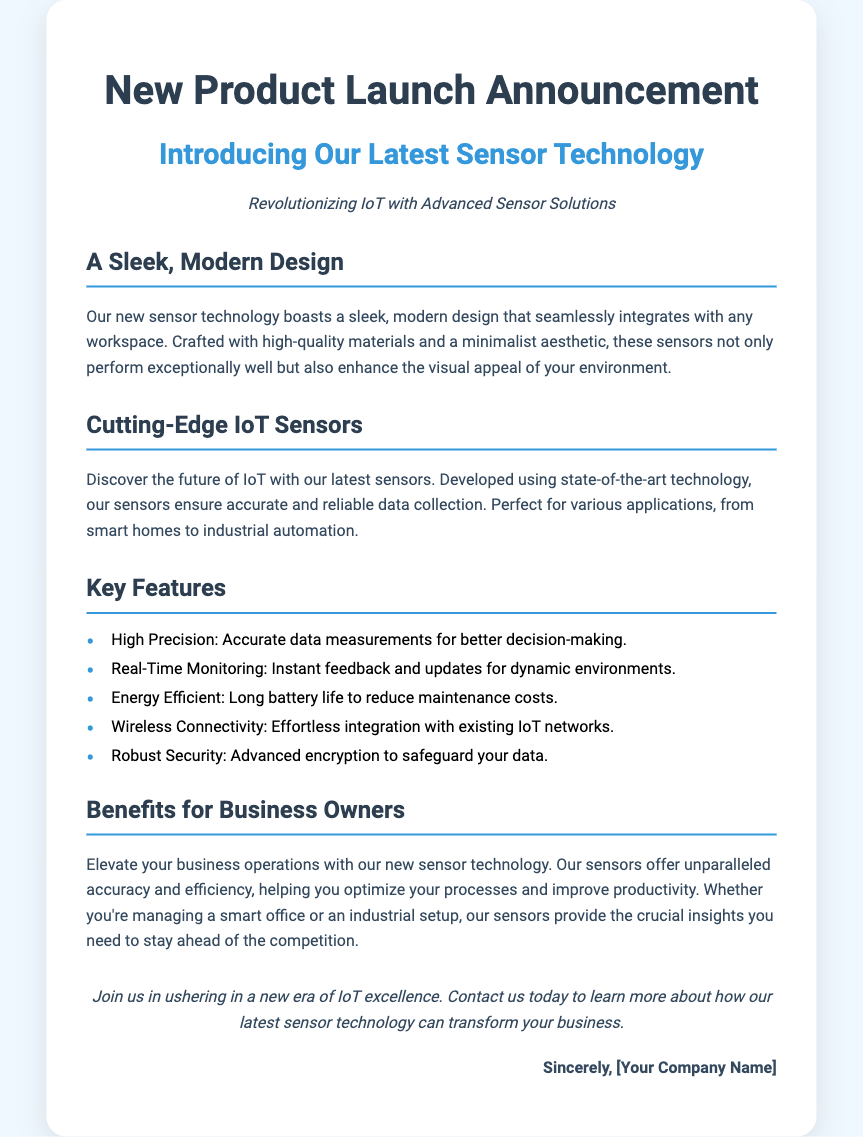What is the title of the announcement? The title of the announcement is provided at the top of the document.
Answer: New Product Launch Announcement What is the main focus of the new technology? The main focus of the new technology is highlighted in the introduction section of the document.
Answer: Latest Sensor Technology What is one key feature of the sensors? The document lists features in a section, providing multiple options.
Answer: High Precision What type of environment is mentioned for these sensors? The document specifies examples of environments suitable for the sensors' applications.
Answer: Smart homes What benefit do the sensors provide for business owners? The benefit for business owners is discussed in a specific section dedicated to benefits.
Answer: Optimize processes What style is emphasized in the design of the sensors? The document describes the design aspect in a section that discusses aesthetics.
Answer: Sleek, modern How many key features are listed in the document? The number of key features can be counted from the list provided.
Answer: Five What is the closing statement's call to action? The closing contains a call to action directing readers on what to do next.
Answer: Contact us today What colors are predominantly used in the document's design? The document’s styling and color choices are reflected in its elements and text.
Answer: Blue and white 